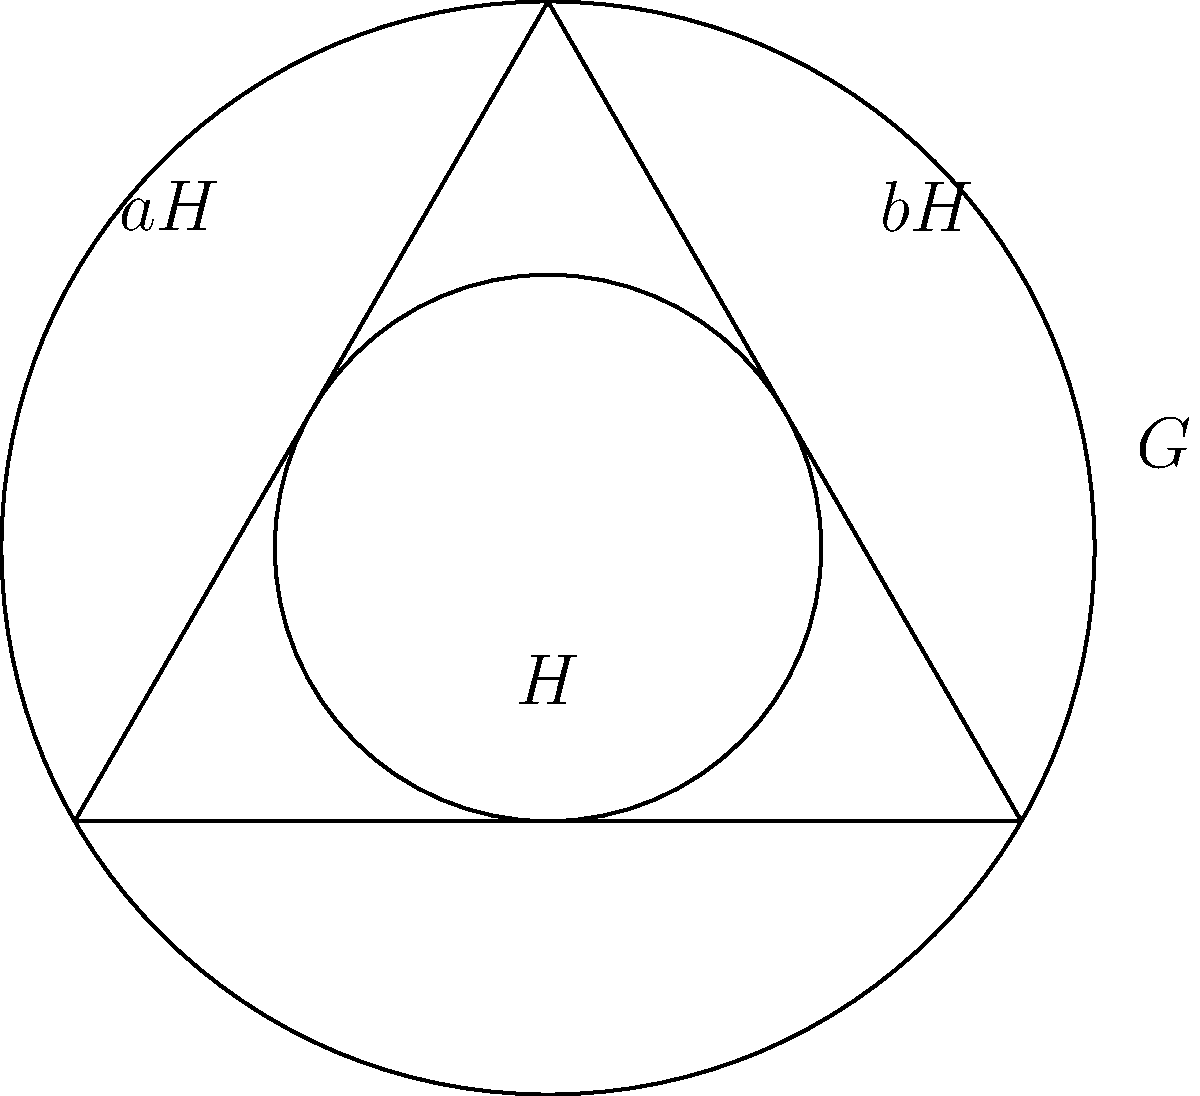Consider a group $G$ represented by the outer circle in the Venn diagram, with a subgroup $H$ represented by the inner circle. The triangle represents three distinct cosets of $H$ in $G$. If $|G| = 18$ and $|H| = 6$, determine the index $[G:H]$ and explain its relationship to the number of cosets visible in the diagram. To solve this problem, we'll follow these steps:

1. Recall the definition of index:
   The index $[G:H]$ is the number of distinct cosets of $H$ in $G$.

2. Calculate the index using the given information:
   $$[G:H] = \frac{|G|}{|H|} = \frac{18}{6} = 3$$

3. Interpret the Venn diagram:
   - The outer circle represents the entire group $G$.
   - The inner circle represents the subgroup $H$.
   - The triangle divides the space between the two circles into three regions.

4. Relate the diagram to cosets:
   - Each region of the triangle represents a distinct coset of $H$ in $G$.
   - We can see three regions, which correspond to the three cosets.

5. Verify the consistency:
   - The number of cosets visible in the diagram (3) matches the calculated index $[G:H] = 3$.

6. Interpret the result:
   - This means that $G$ can be partitioned into 3 distinct cosets of $H$.
   - Each coset has the same number of elements as $H$, which is 6.
   - This partitioning is visually represented by the three regions of the triangle in the diagram.

Therefore, the index $[G:H] = 3$ corresponds exactly to the number of cosets (triangle regions) visible in the Venn diagram, confirming the relationship between the algebraic calculation and the geometric representation.
Answer: $[G:H] = 3$, matching the three cosets (triangle regions) in the diagram. 